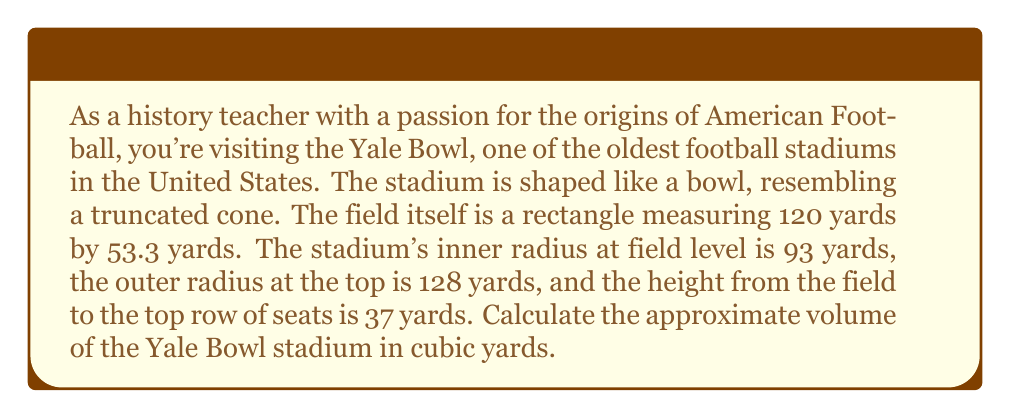Can you solve this math problem? To solve this problem, we need to follow these steps:

1. Calculate the volume of the entire cone.
2. Calculate the volume of the small cone that's been "cut off" from the top.
3. Subtract the small cone's volume from the large cone's volume.

Let's begin:

1. For the large cone:
   - Radius (R) = 128 yards
   - Height (H) can be found using similar triangles:
     $$\frac{128}{H} = \frac{35}{37}$$
     $$H = \frac{128 * 37}{35} = 135.31 \text{ yards}$$
   
   Volume of large cone: $$V_1 = \frac{1}{3}\pi R^2 H = \frac{1}{3}\pi * 128^2 * 135.31 = 731,639.62 \text{ cubic yards}$$

2. For the small cone:
   - Radius (r) = 93 yards
   - Height (h) = 135.31 - 37 = 98.31 yards
   
   Volume of small cone: $$V_2 = \frac{1}{3}\pi r^2 h = \frac{1}{3}\pi * 93^2 * 98.31 = 280,828.76 \text{ cubic yards}$$

3. Volume of the truncated cone (stadium):
   $$V_{stadium} = V_1 - V_2 = 731,639.62 - 280,828.76 = 450,810.86 \text{ cubic yards}$$

[asy]
import geometry;

size(200);
pair A = (0,0), B = (128,135.31), C = (128,0), D = (93,98.31), E = (93,0);
draw(A--B--C--cycle);
draw(D--E);
label("128", (C+B)/2, E);
label("93", (D+E)/2, W);
label("135.31", (A+B)/2, NW);
label("37", (D+E)/2, E);
[/asy]
Answer: The approximate volume of the Yale Bowl stadium is 450,811 cubic yards. 